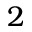<formula> <loc_0><loc_0><loc_500><loc_500>2</formula> 